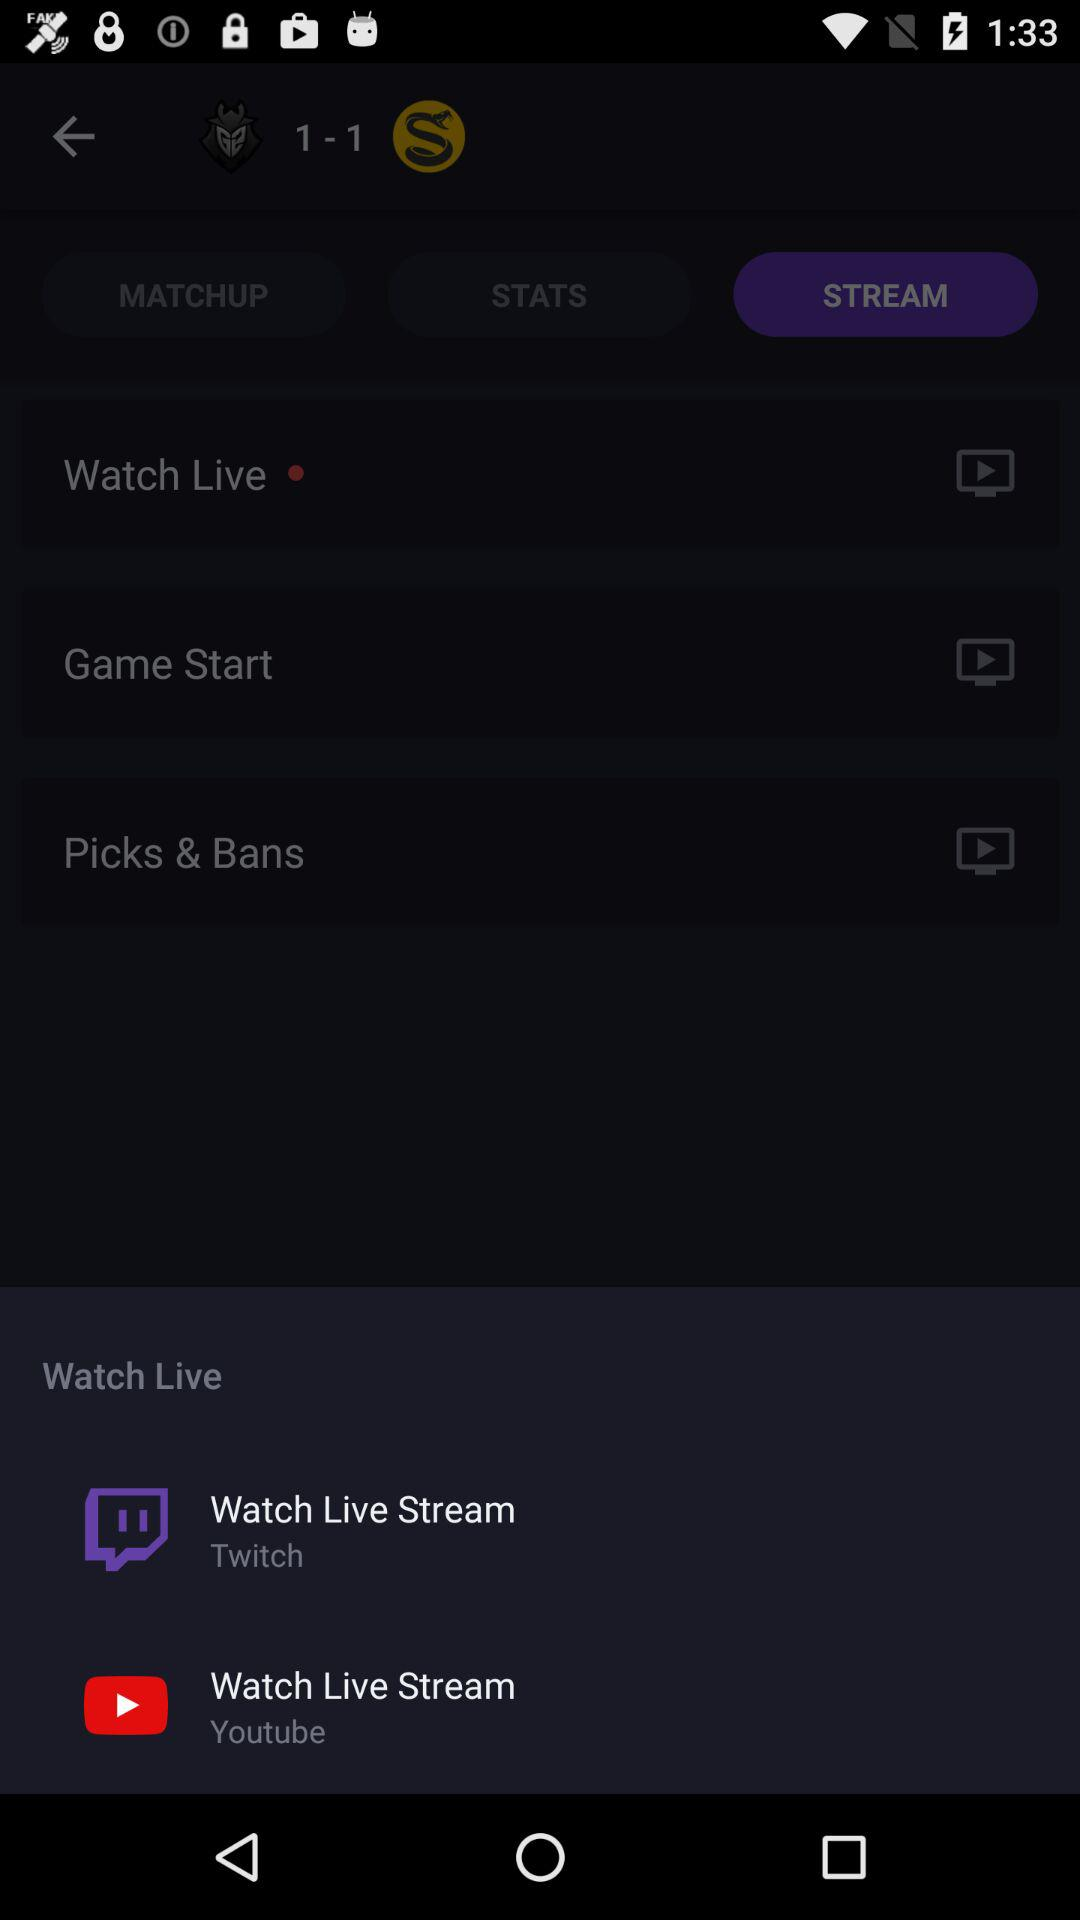Which tab is open? The open tab is "STREAM". 